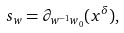<formula> <loc_0><loc_0><loc_500><loc_500>\ s _ { w } = \partial _ { w ^ { - 1 } w _ { 0 } } ( x ^ { \delta } ) ,</formula> 